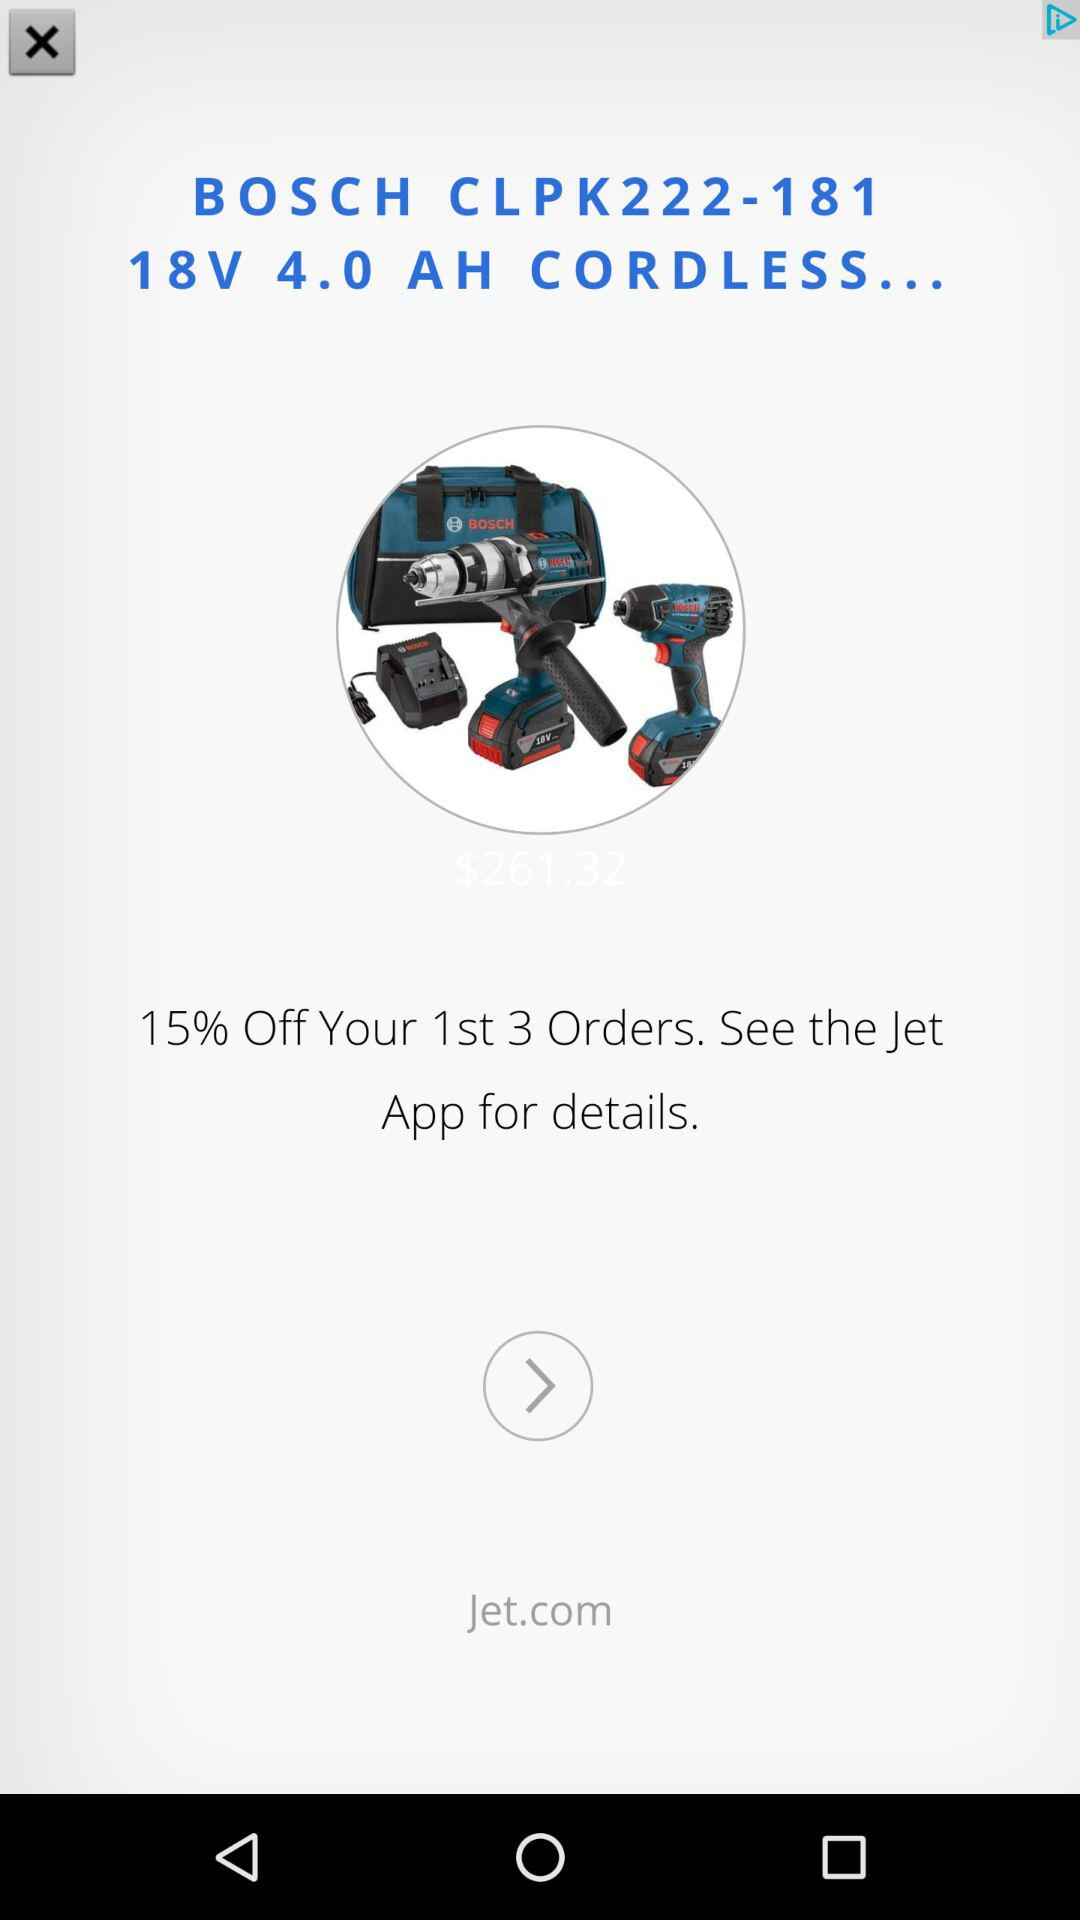How much is the discount for the first 3 orders?
Answer the question using a single word or phrase. 15% 